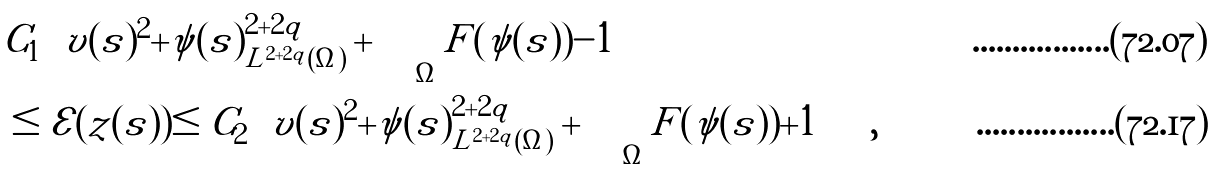Convert formula to latex. <formula><loc_0><loc_0><loc_500><loc_500>& C _ { 1 } \left ( \| v ( s ) \| ^ { 2 } + \| \psi ( s ) \| _ { L ^ { 2 + 2 q } ( \Omega ) } ^ { 2 + 2 q } + \int _ { \Omega } F ( \psi ( s ) ) - 1 \right ) \\ & \leq \mathcal { E } ( z ( s ) ) \leq C _ { 2 } \left ( \| v ( s ) \| ^ { 2 } + \| \psi ( s ) \| _ { L ^ { 2 + 2 q } ( \Omega ) } ^ { 2 + 2 q } + \int _ { \Omega } F ( \psi ( s ) ) + 1 \right ) ,</formula> 